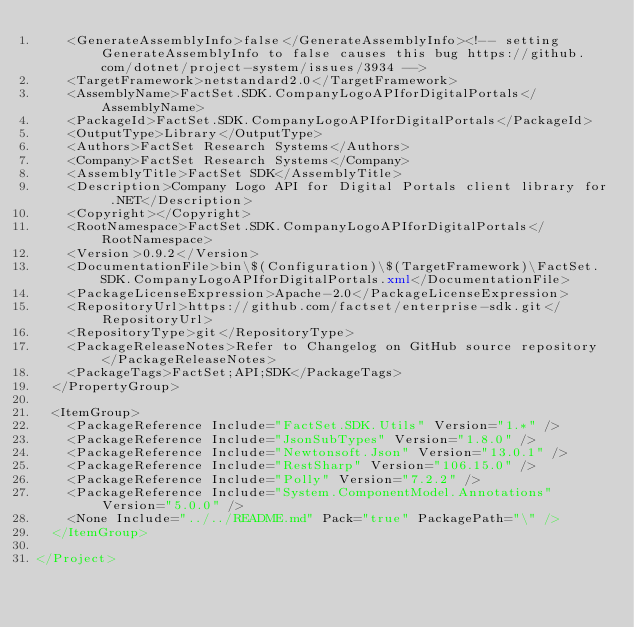Convert code to text. <code><loc_0><loc_0><loc_500><loc_500><_XML_>    <GenerateAssemblyInfo>false</GenerateAssemblyInfo><!-- setting GenerateAssemblyInfo to false causes this bug https://github.com/dotnet/project-system/issues/3934 -->
    <TargetFramework>netstandard2.0</TargetFramework>
    <AssemblyName>FactSet.SDK.CompanyLogoAPIforDigitalPortals</AssemblyName>
    <PackageId>FactSet.SDK.CompanyLogoAPIforDigitalPortals</PackageId>
    <OutputType>Library</OutputType>
    <Authors>FactSet Research Systems</Authors>
    <Company>FactSet Research Systems</Company>
    <AssemblyTitle>FactSet SDK</AssemblyTitle>
    <Description>Company Logo API for Digital Portals client library for .NET</Description>
    <Copyright></Copyright>
    <RootNamespace>FactSet.SDK.CompanyLogoAPIforDigitalPortals</RootNamespace>
    <Version>0.9.2</Version>
    <DocumentationFile>bin\$(Configuration)\$(TargetFramework)\FactSet.SDK.CompanyLogoAPIforDigitalPortals.xml</DocumentationFile>
    <PackageLicenseExpression>Apache-2.0</PackageLicenseExpression>
    <RepositoryUrl>https://github.com/factset/enterprise-sdk.git</RepositoryUrl>
    <RepositoryType>git</RepositoryType>
    <PackageReleaseNotes>Refer to Changelog on GitHub source repository</PackageReleaseNotes>
    <PackageTags>FactSet;API;SDK</PackageTags>
  </PropertyGroup>

  <ItemGroup>
    <PackageReference Include="FactSet.SDK.Utils" Version="1.*" />
    <PackageReference Include="JsonSubTypes" Version="1.8.0" />
    <PackageReference Include="Newtonsoft.Json" Version="13.0.1" />
    <PackageReference Include="RestSharp" Version="106.15.0" />
    <PackageReference Include="Polly" Version="7.2.2" />
    <PackageReference Include="System.ComponentModel.Annotations" Version="5.0.0" />
    <None Include="../../README.md" Pack="true" PackagePath="\" />
  </ItemGroup>

</Project>
</code> 